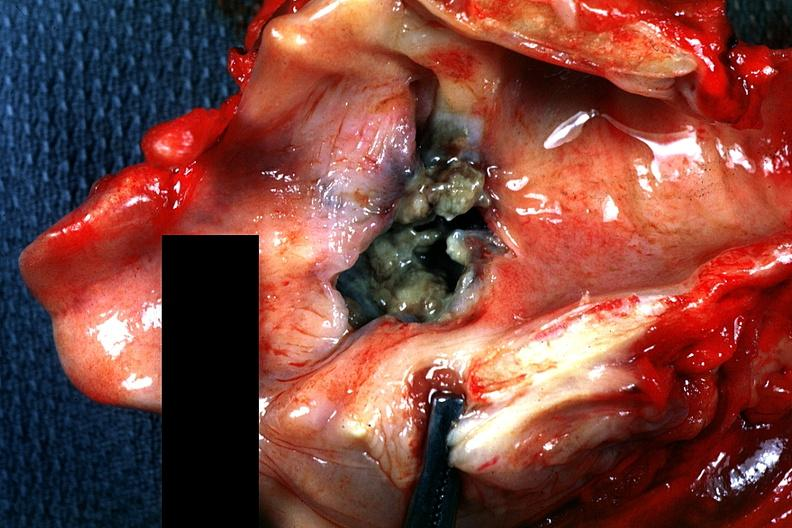where is this?
Answer the question using a single word or phrase. Oral 